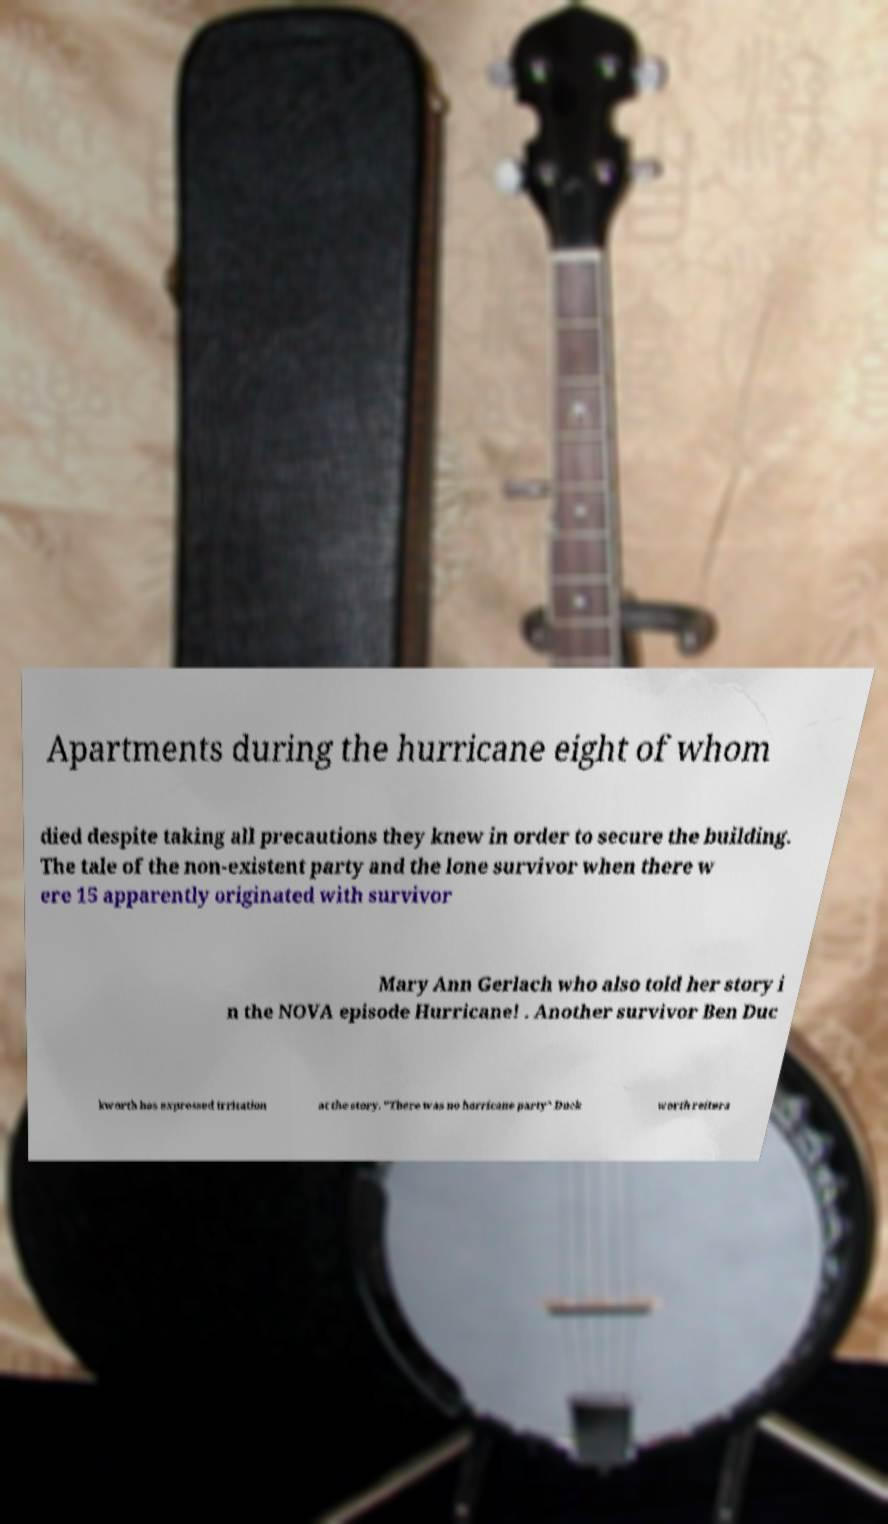Can you accurately transcribe the text from the provided image for me? Apartments during the hurricane eight of whom died despite taking all precautions they knew in order to secure the building. The tale of the non-existent party and the lone survivor when there w ere 15 apparently originated with survivor Mary Ann Gerlach who also told her story i n the NOVA episode Hurricane! . Another survivor Ben Duc kworth has expressed irritation at the story. "There was no hurricane party" Duck worth reitera 